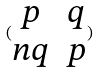<formula> <loc_0><loc_0><loc_500><loc_500>( \begin{matrix} p & q \\ n q & p \end{matrix} )</formula> 